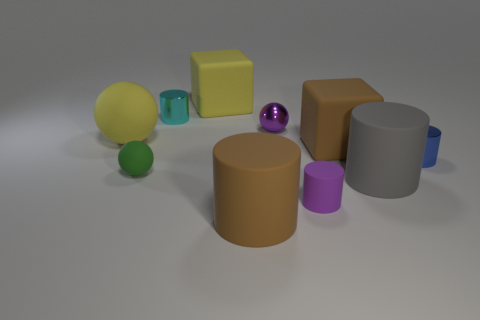What colors are the spheres in the image? In the image, there are spheres of three different colors: one is yellow, another is green, and the last one is purple. 